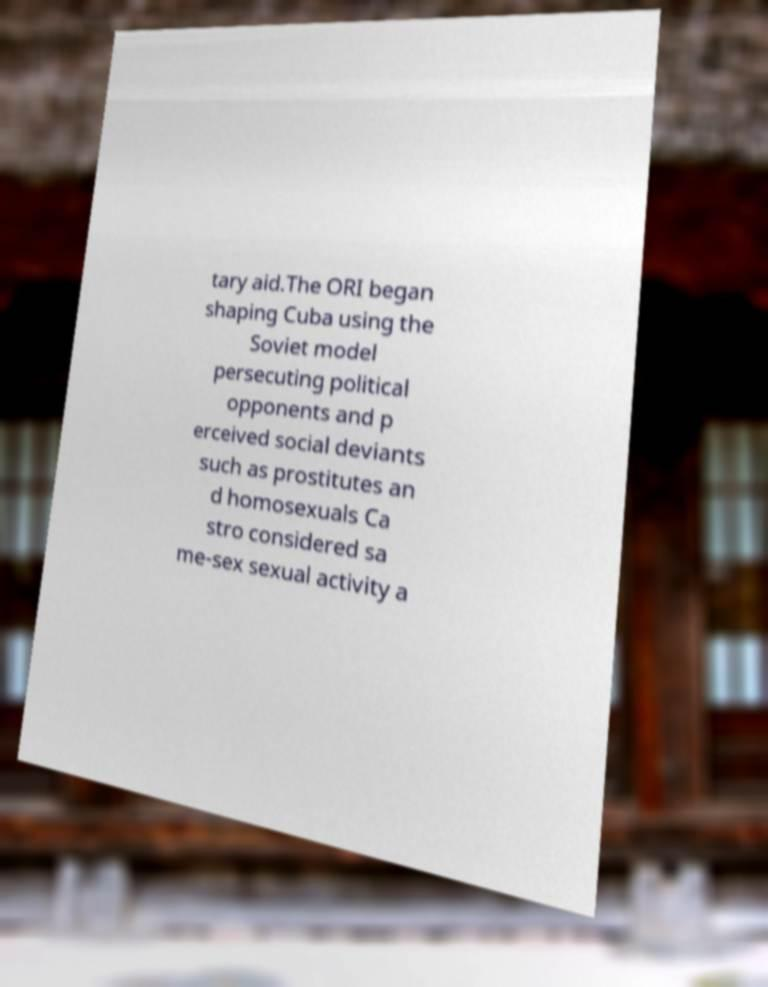I need the written content from this picture converted into text. Can you do that? tary aid.The ORI began shaping Cuba using the Soviet model persecuting political opponents and p erceived social deviants such as prostitutes an d homosexuals Ca stro considered sa me-sex sexual activity a 